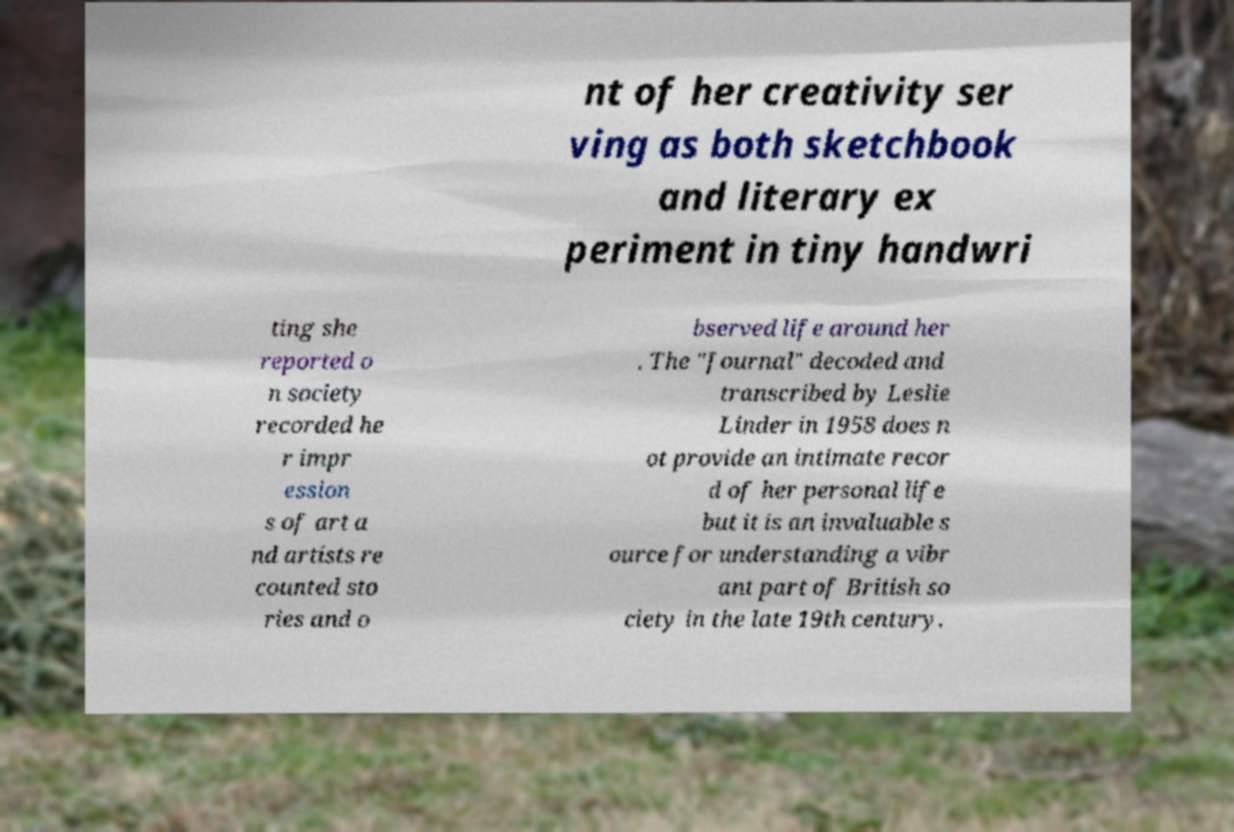Can you accurately transcribe the text from the provided image for me? nt of her creativity ser ving as both sketchbook and literary ex periment in tiny handwri ting she reported o n society recorded he r impr ession s of art a nd artists re counted sto ries and o bserved life around her . The "Journal" decoded and transcribed by Leslie Linder in 1958 does n ot provide an intimate recor d of her personal life but it is an invaluable s ource for understanding a vibr ant part of British so ciety in the late 19th century. 